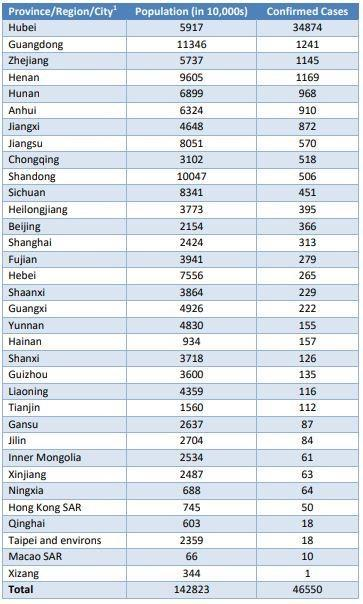Which Chinese province has reported the highest number of confirmed COVID-19 cases?
Answer the question with a short phrase. Hubei What is the population (in 10,000s) of Sichuan? 8341 What is the population (in 10,000s) of Gansu? 2637 What is the number of confirmed COVID-19 cases in Hunan? 968 Which region in China has reported the least number of confirmed COVID-19 cases? Xizang 